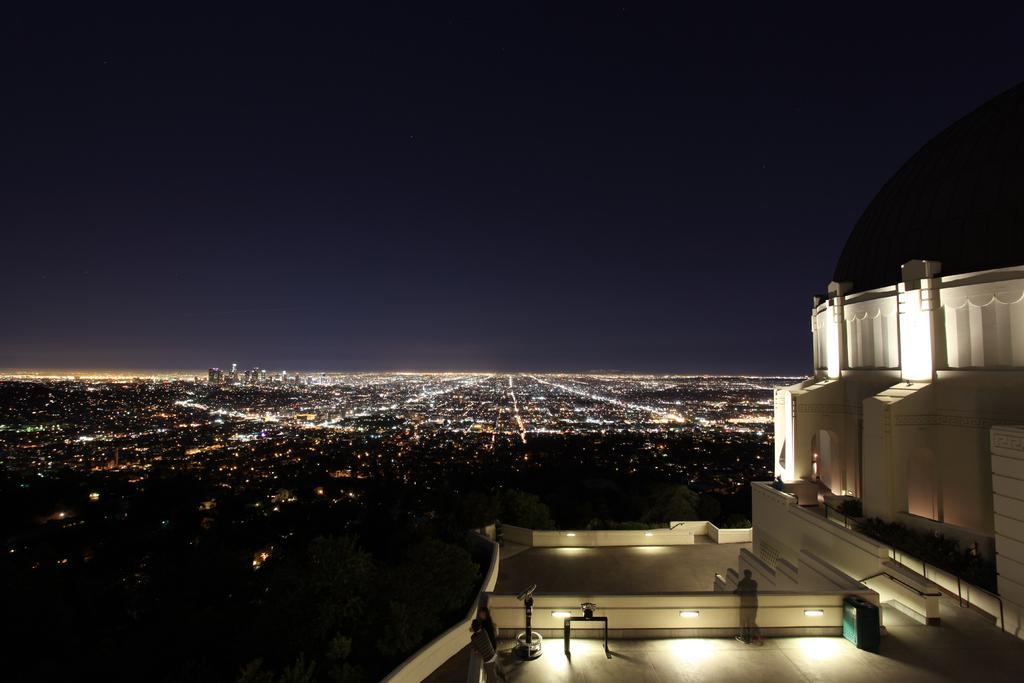How would you summarize this image in a sentence or two? In this image, we can see a building with walls, lights. Here we can see few people are standing, some objects and plants. Background we can see light and sky. 